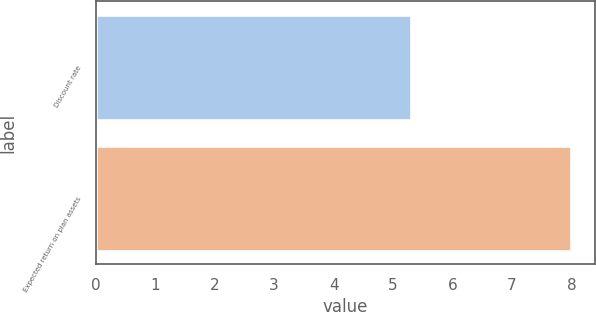Convert chart to OTSL. <chart><loc_0><loc_0><loc_500><loc_500><bar_chart><fcel>Discount rate<fcel>Expected return on plan assets<nl><fcel>5.3<fcel>8<nl></chart> 